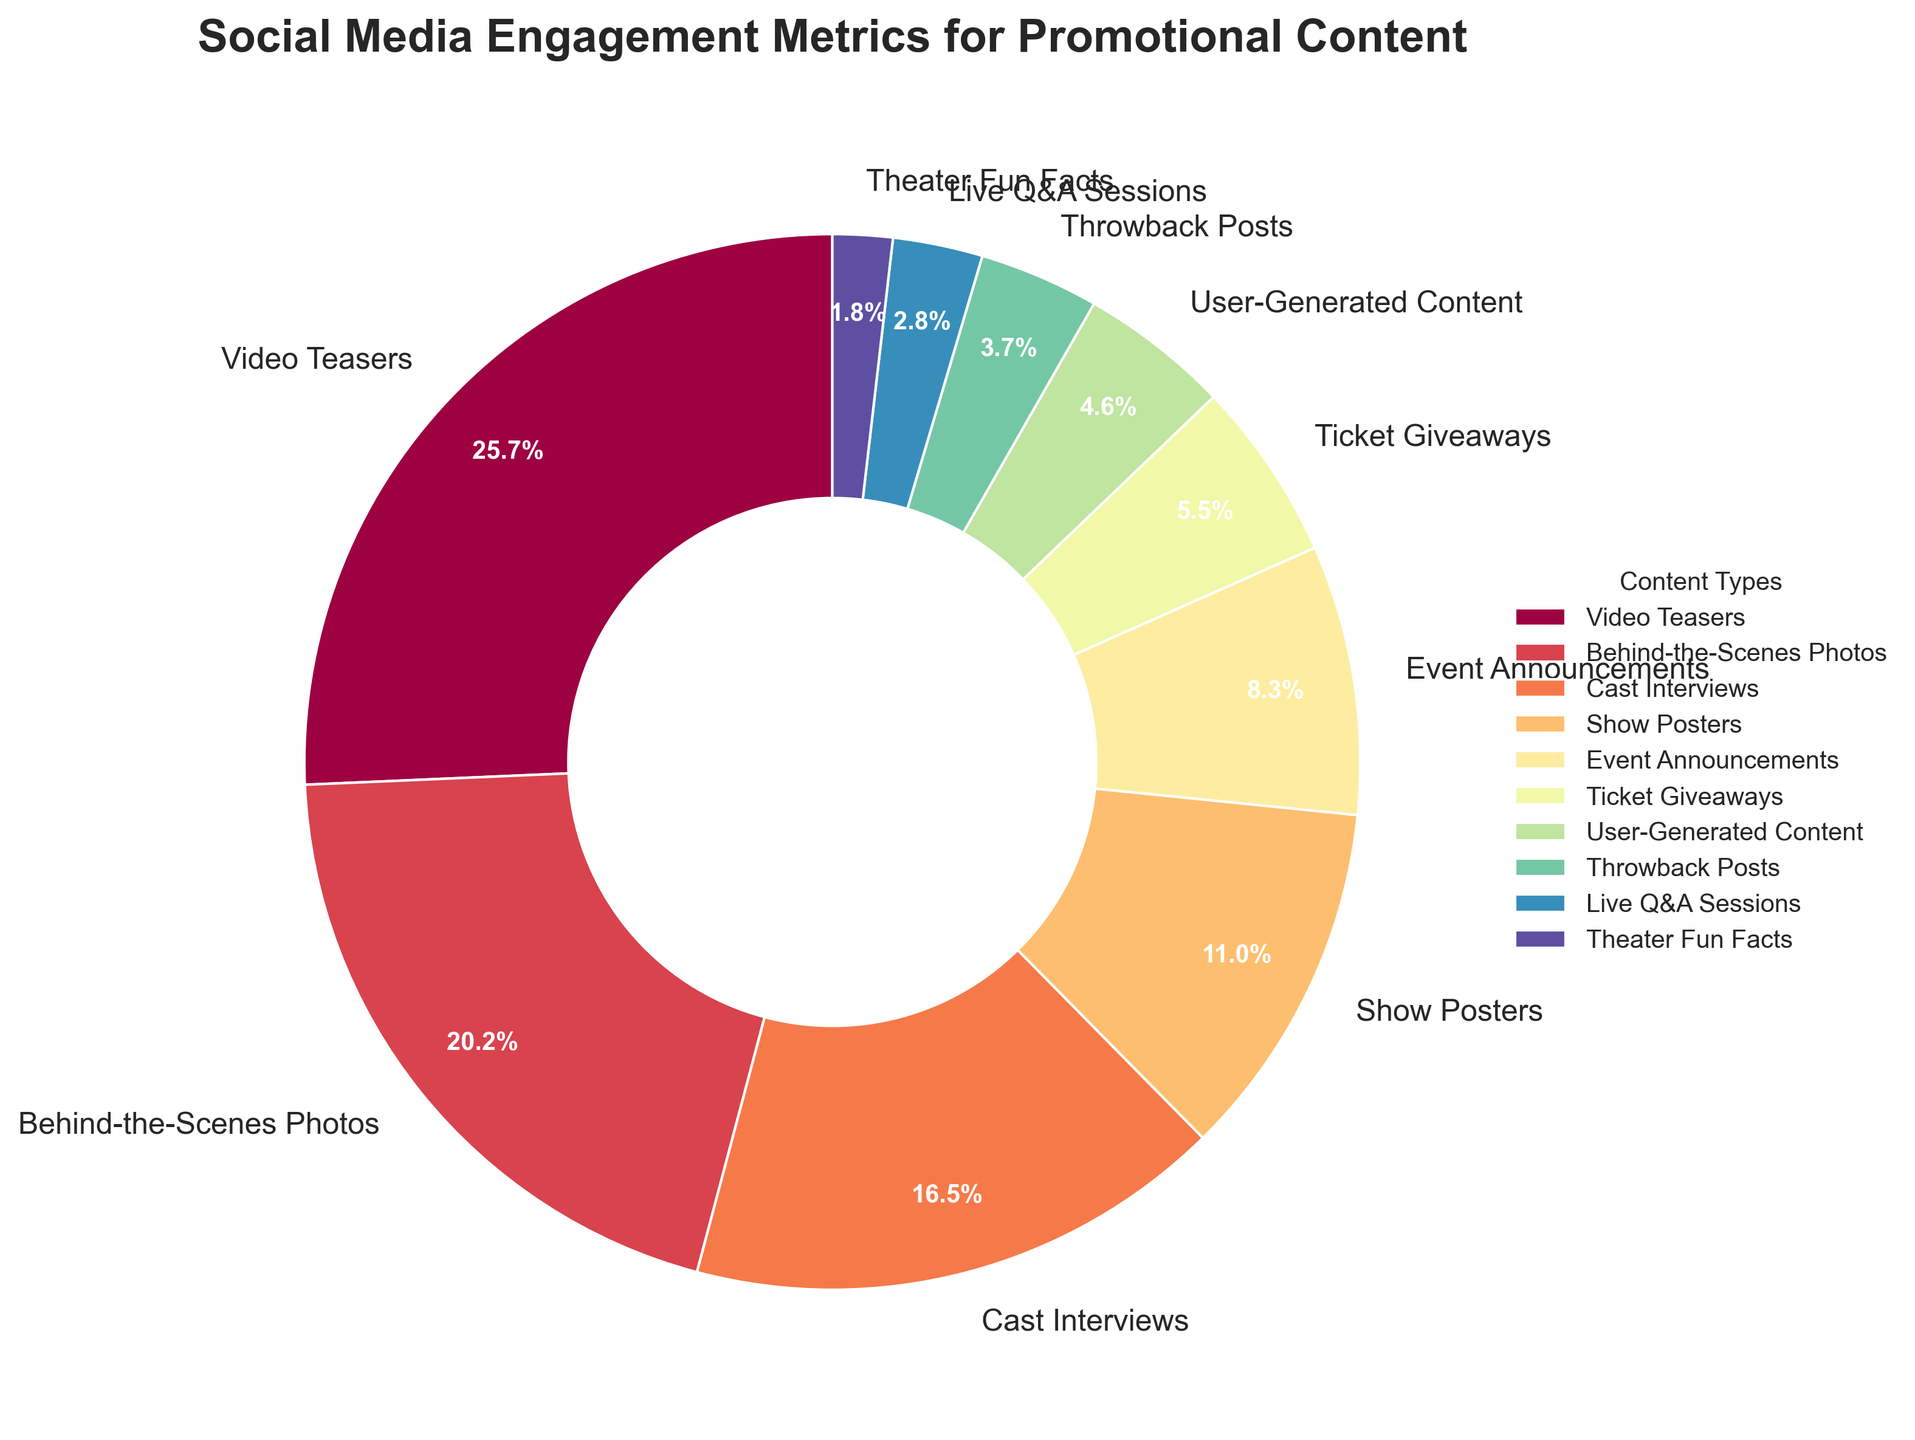What's the most engaging type of promotional content? The figure shows different types of promotional content with their engagement percentages. The content type with the highest percentage is the most engaging. In this case, it's Video Teasers with 28%.
Answer: Video Teasers Which content type has the lowest engagement? The figure includes different types of promotional content with their engagement percentages. The content type with the lowest percentage is the one with the smallest segment. Here, it's Theater Fun Facts with 2%.
Answer: Theater Fun Facts What is the combined engagement percentage for Behind-the-Scenes Photos and Cast Interviews? To find the combined engagement percentage, add the percentages of Behind-the-Scenes Photos (22%) and Cast Interviews (18%). The total is 22% + 18% = 40%.
Answer: 40% How does the engagement for Event Announcements compare to that for Show Posters? The figure displays engagement percentages for both Event Announcements (9%) and Show Posters (12%). Comparing these values, the engagement for Show Posters is 3% higher than Event Announcements.
Answer: Show Posters has 3% higher engagement What is the total percentage of engagement for all content types except Video Teasers? Video Teasers account for 28%. To get the engagement for all other types, subtract 28% from 100%. So, 100% - 28% = 72%.
Answer: 72% How many content types have an engagement percentage greater than 10%? Examine the segments in the figure to count the content types with percentages more than 10%. The content types are Video Teasers (28%), Behind-the-Scenes Photos (22%), and Cast Interviews (18%), and Show Posters (12%). There are 4 content types meeting this criteria.
Answer: 4 Which has greater engagement: Ticket Giveaways or User-Generated Content? The figure shows the engagement percentages for Ticket Giveaways (6%) and User-Generated Content (5%). Comparing these, Ticket Giveaways have a higher engagement percentage.
Answer: Ticket Giveaways Add the engagement percentages of Live Q&A Sessions and Theater Fun Facts. What is the sum? Add the engagement percentages of Live Q&A Sessions (3%) and Theater Fun Facts (2%). The total is 3% + 2% = 5%.
Answer: 5% How does the visual size of the segment for Throwback Posts compare to that of Live Q&A Sessions? Visually inspect the pie chart to compare the sizes of the segments for Throwback Posts (4%) and Live Q&A Sessions (3%). The segment for Throwback Posts is slightly larger.
Answer: Throwback Posts is larger Which content types have an engagement percentage less than the average engagement percentage of all types? Calculate the average engagement percentage by summing all percentages and dividing by the number of content types. The sum is 28 + 22 + 18 + 12 + 9 + 6 + 5 + 4 + 3 + 2 = 109 and there are 10 types. So, 109/10 = 10.9%. Content types with less than 10.9% are Event Announcements (9%), Ticket Giveaways (6%), User-Generated Content (5%), Throwback Posts (4%), Live Q&A Sessions (3%), and Theater Fun Facts (2%).
Answer: Event Announcements, Ticket Giveaways, User-Generated Content, Throwback Posts, Live Q&A Sessions, and Theater Fun Facts 